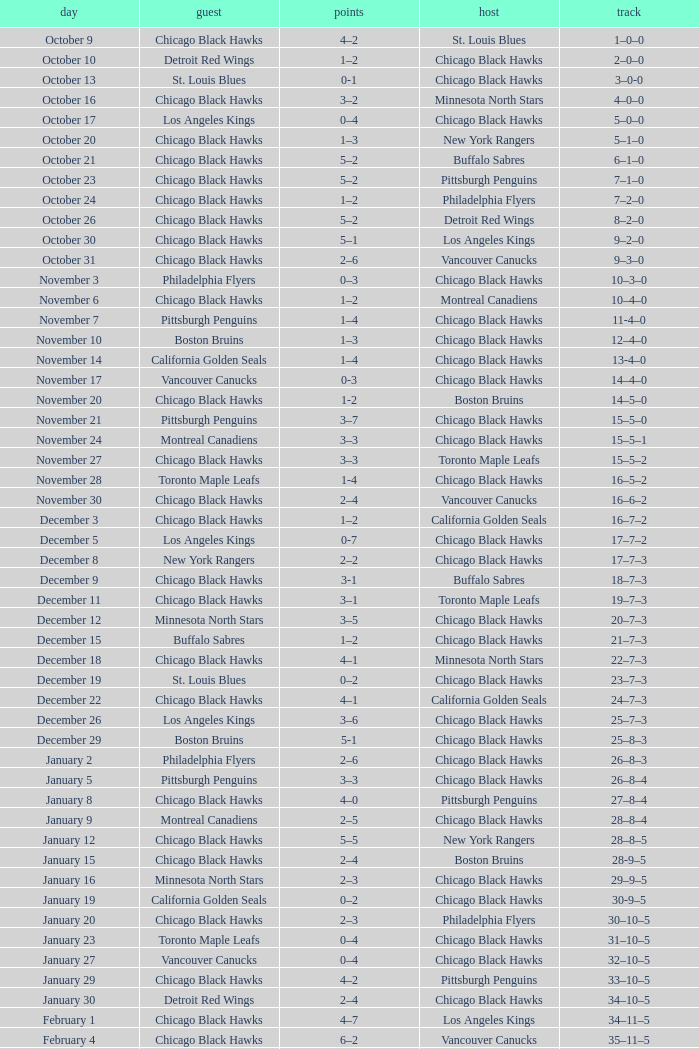What is the Record of the February 26 date? 39–16–7. 